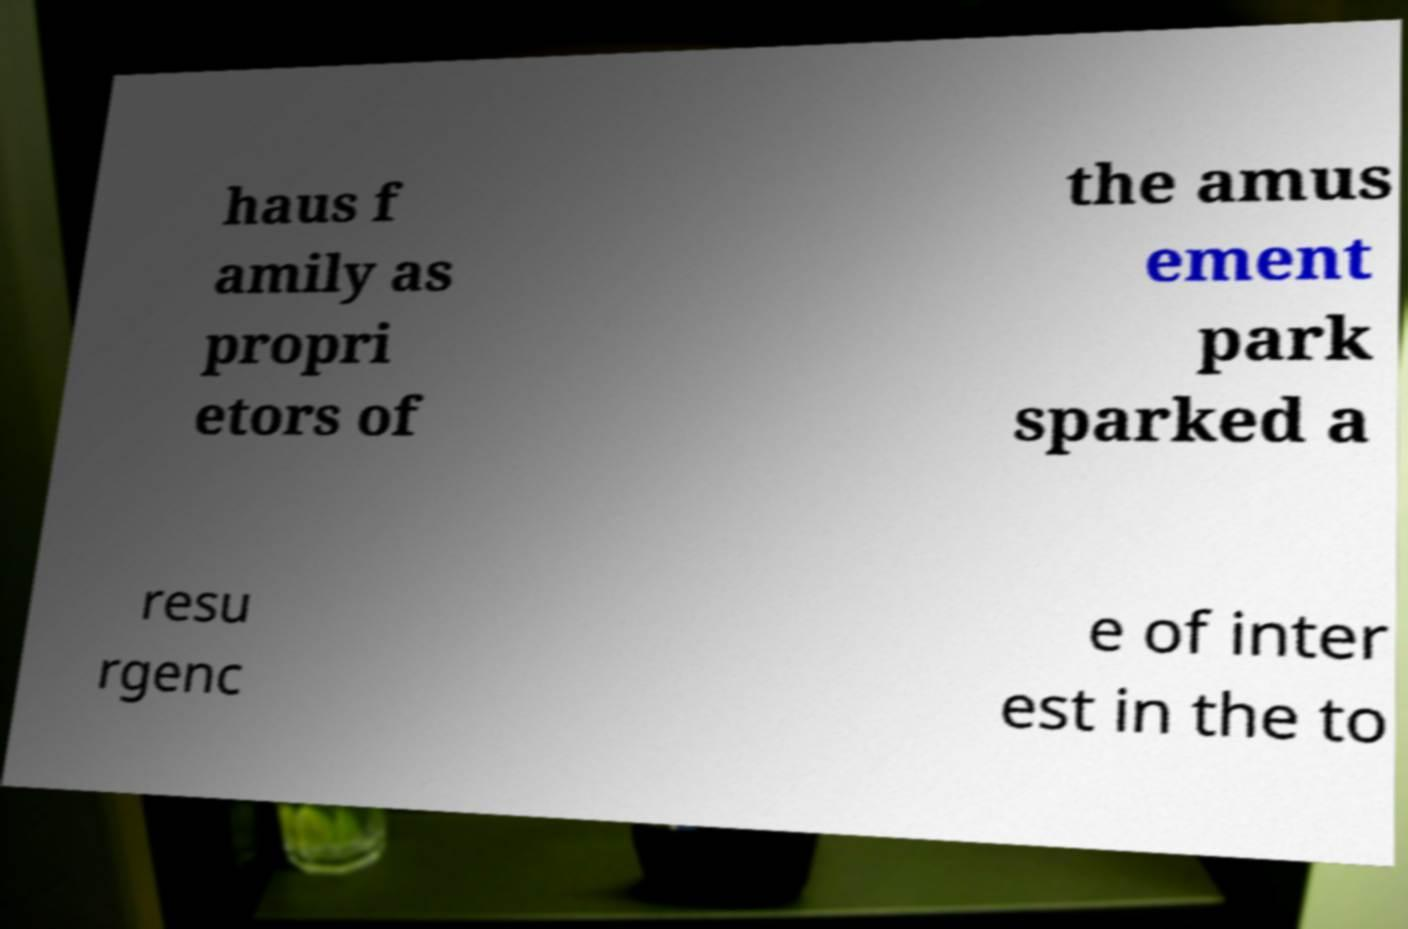There's text embedded in this image that I need extracted. Can you transcribe it verbatim? haus f amily as propri etors of the amus ement park sparked a resu rgenc e of inter est in the to 